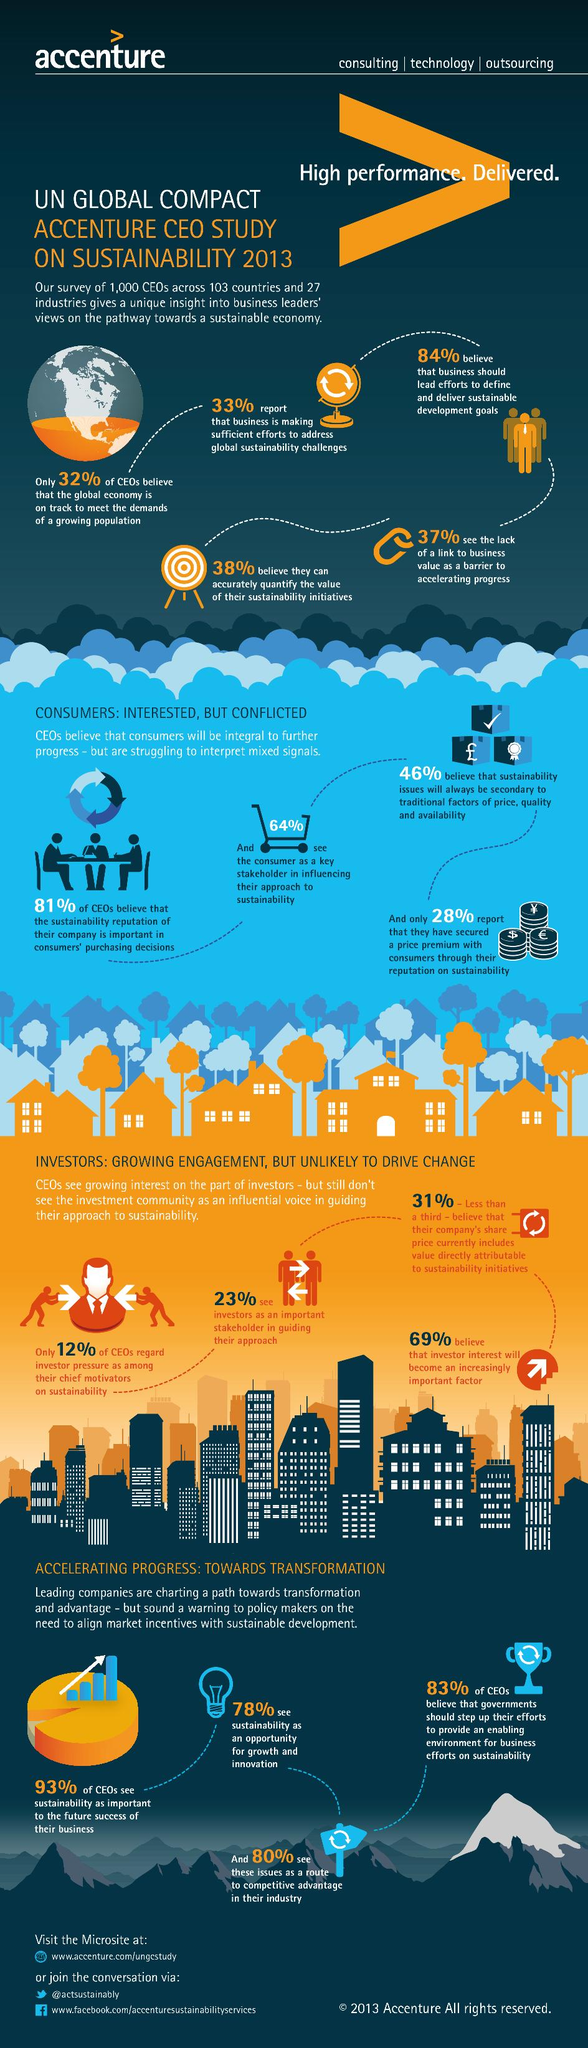Draw attention to some important aspects in this diagram. According to the survey, only 7% of CEOs did not consider sustainability as crucial for the future success of their business. According to the survey, 78% of CEOs perceive sustainability as an opportunity for growth and innovation. According to the survey, 36% of CEOs did not consider the consumer as a key stakeholder in shaping their approach to sustainability. According to the survey, 37% of CEOs believe that the lack of a clear connection to business value is a significant obstacle in hastening progress. 